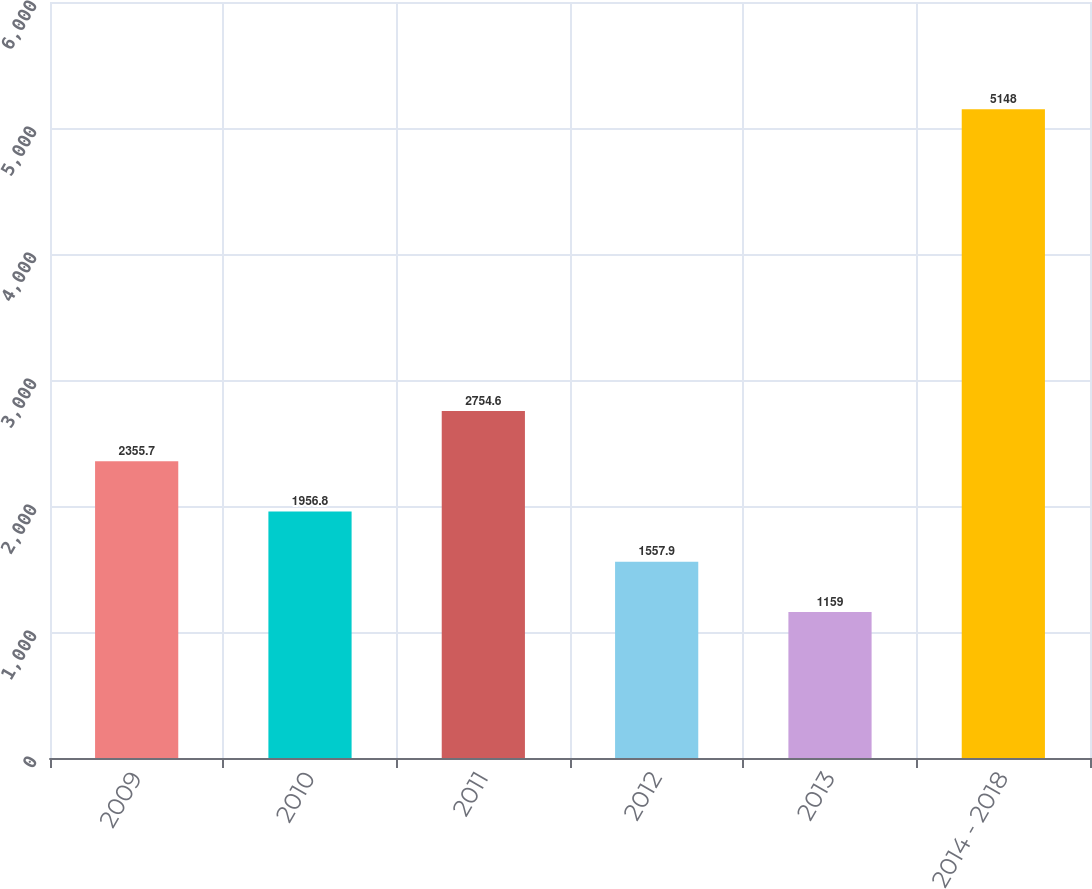Convert chart to OTSL. <chart><loc_0><loc_0><loc_500><loc_500><bar_chart><fcel>2009<fcel>2010<fcel>2011<fcel>2012<fcel>2013<fcel>2014 - 2018<nl><fcel>2355.7<fcel>1956.8<fcel>2754.6<fcel>1557.9<fcel>1159<fcel>5148<nl></chart> 